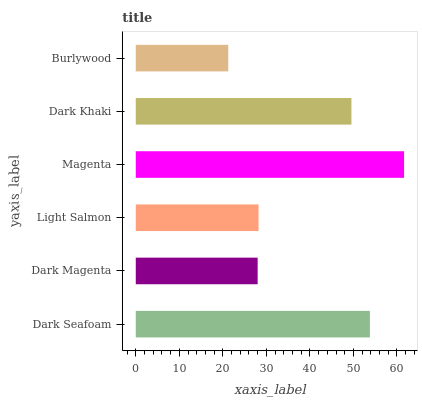Is Burlywood the minimum?
Answer yes or no. Yes. Is Magenta the maximum?
Answer yes or no. Yes. Is Dark Magenta the minimum?
Answer yes or no. No. Is Dark Magenta the maximum?
Answer yes or no. No. Is Dark Seafoam greater than Dark Magenta?
Answer yes or no. Yes. Is Dark Magenta less than Dark Seafoam?
Answer yes or no. Yes. Is Dark Magenta greater than Dark Seafoam?
Answer yes or no. No. Is Dark Seafoam less than Dark Magenta?
Answer yes or no. No. Is Dark Khaki the high median?
Answer yes or no. Yes. Is Light Salmon the low median?
Answer yes or no. Yes. Is Dark Seafoam the high median?
Answer yes or no. No. Is Magenta the low median?
Answer yes or no. No. 